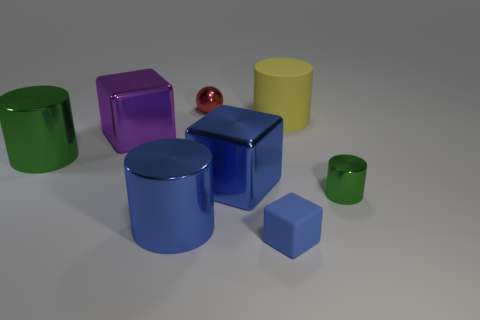Add 2 large purple metal balls. How many objects exist? 10 Subtract all yellow cylinders. Subtract all cyan spheres. How many cylinders are left? 3 Subtract all blocks. How many objects are left? 5 Subtract 0 cyan cylinders. How many objects are left? 8 Subtract all large cyan cylinders. Subtract all small green cylinders. How many objects are left? 7 Add 5 big yellow rubber cylinders. How many big yellow rubber cylinders are left? 6 Add 8 blue rubber cylinders. How many blue rubber cylinders exist? 8 